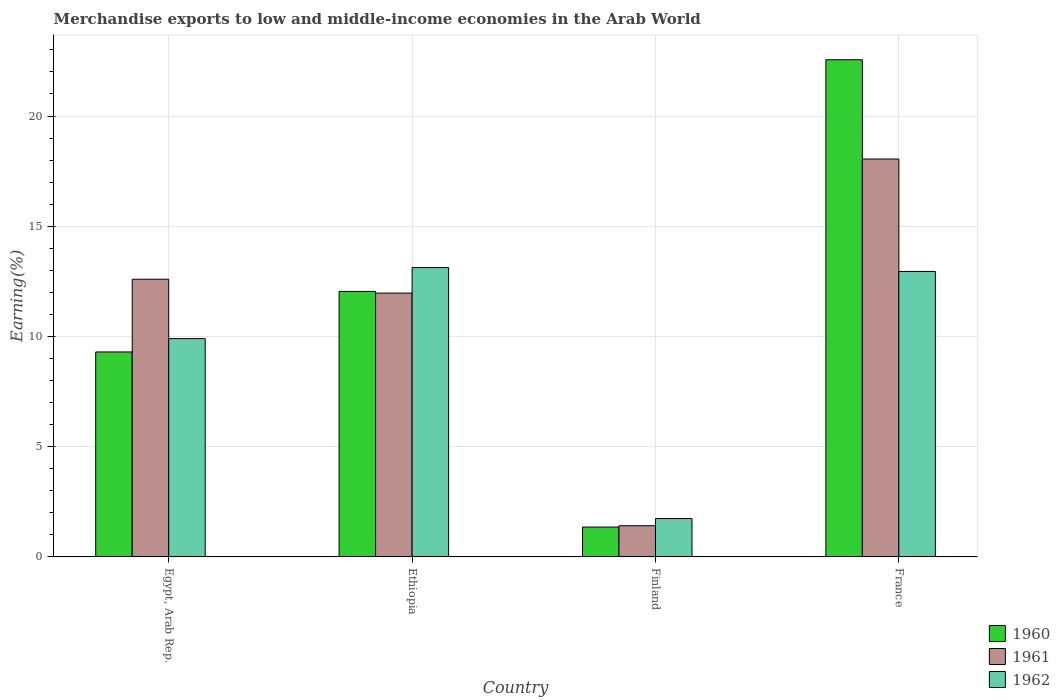How many groups of bars are there?
Provide a short and direct response. 4. Are the number of bars per tick equal to the number of legend labels?
Offer a very short reply. Yes. How many bars are there on the 3rd tick from the right?
Provide a short and direct response. 3. What is the label of the 2nd group of bars from the left?
Your response must be concise. Ethiopia. What is the percentage of amount earned from merchandise exports in 1961 in Egypt, Arab Rep.?
Your answer should be compact. 12.6. Across all countries, what is the maximum percentage of amount earned from merchandise exports in 1961?
Your answer should be very brief. 18.05. Across all countries, what is the minimum percentage of amount earned from merchandise exports in 1960?
Make the answer very short. 1.36. In which country was the percentage of amount earned from merchandise exports in 1961 maximum?
Provide a short and direct response. France. What is the total percentage of amount earned from merchandise exports in 1962 in the graph?
Your answer should be compact. 37.72. What is the difference between the percentage of amount earned from merchandise exports in 1960 in Egypt, Arab Rep. and that in Ethiopia?
Offer a terse response. -2.75. What is the difference between the percentage of amount earned from merchandise exports in 1960 in France and the percentage of amount earned from merchandise exports in 1961 in Ethiopia?
Offer a terse response. 10.58. What is the average percentage of amount earned from merchandise exports in 1961 per country?
Your response must be concise. 11.01. What is the difference between the percentage of amount earned from merchandise exports of/in 1962 and percentage of amount earned from merchandise exports of/in 1960 in Ethiopia?
Your answer should be very brief. 1.08. What is the ratio of the percentage of amount earned from merchandise exports in 1962 in Finland to that in France?
Make the answer very short. 0.13. Is the difference between the percentage of amount earned from merchandise exports in 1962 in Ethiopia and France greater than the difference between the percentage of amount earned from merchandise exports in 1960 in Ethiopia and France?
Provide a short and direct response. Yes. What is the difference between the highest and the second highest percentage of amount earned from merchandise exports in 1961?
Your response must be concise. 6.08. What is the difference between the highest and the lowest percentage of amount earned from merchandise exports in 1960?
Keep it short and to the point. 21.2. How many bars are there?
Give a very brief answer. 12. Are all the bars in the graph horizontal?
Provide a succinct answer. No. What is the difference between two consecutive major ticks on the Y-axis?
Your answer should be very brief. 5. Are the values on the major ticks of Y-axis written in scientific E-notation?
Give a very brief answer. No. Does the graph contain any zero values?
Your answer should be very brief. No. What is the title of the graph?
Ensure brevity in your answer.  Merchandise exports to low and middle-income economies in the Arab World. Does "1966" appear as one of the legend labels in the graph?
Provide a succinct answer. No. What is the label or title of the Y-axis?
Your answer should be very brief. Earning(%). What is the Earning(%) in 1960 in Egypt, Arab Rep.?
Give a very brief answer. 9.3. What is the Earning(%) of 1961 in Egypt, Arab Rep.?
Your answer should be compact. 12.6. What is the Earning(%) of 1962 in Egypt, Arab Rep.?
Your response must be concise. 9.9. What is the Earning(%) of 1960 in Ethiopia?
Provide a short and direct response. 12.04. What is the Earning(%) in 1961 in Ethiopia?
Provide a short and direct response. 11.97. What is the Earning(%) in 1962 in Ethiopia?
Provide a succinct answer. 13.12. What is the Earning(%) in 1960 in Finland?
Give a very brief answer. 1.36. What is the Earning(%) of 1961 in Finland?
Offer a terse response. 1.42. What is the Earning(%) of 1962 in Finland?
Provide a succinct answer. 1.74. What is the Earning(%) of 1960 in France?
Your response must be concise. 22.55. What is the Earning(%) of 1961 in France?
Give a very brief answer. 18.05. What is the Earning(%) in 1962 in France?
Give a very brief answer. 12.95. Across all countries, what is the maximum Earning(%) in 1960?
Your answer should be very brief. 22.55. Across all countries, what is the maximum Earning(%) of 1961?
Provide a succinct answer. 18.05. Across all countries, what is the maximum Earning(%) of 1962?
Ensure brevity in your answer.  13.12. Across all countries, what is the minimum Earning(%) of 1960?
Your answer should be compact. 1.36. Across all countries, what is the minimum Earning(%) in 1961?
Your answer should be very brief. 1.42. Across all countries, what is the minimum Earning(%) of 1962?
Offer a terse response. 1.74. What is the total Earning(%) of 1960 in the graph?
Keep it short and to the point. 45.25. What is the total Earning(%) of 1961 in the graph?
Your answer should be compact. 44.03. What is the total Earning(%) in 1962 in the graph?
Your answer should be very brief. 37.72. What is the difference between the Earning(%) in 1960 in Egypt, Arab Rep. and that in Ethiopia?
Give a very brief answer. -2.75. What is the difference between the Earning(%) of 1961 in Egypt, Arab Rep. and that in Ethiopia?
Offer a very short reply. 0.63. What is the difference between the Earning(%) of 1962 in Egypt, Arab Rep. and that in Ethiopia?
Your response must be concise. -3.22. What is the difference between the Earning(%) of 1960 in Egypt, Arab Rep. and that in Finland?
Provide a short and direct response. 7.94. What is the difference between the Earning(%) in 1961 in Egypt, Arab Rep. and that in Finland?
Keep it short and to the point. 11.18. What is the difference between the Earning(%) of 1962 in Egypt, Arab Rep. and that in Finland?
Offer a terse response. 8.16. What is the difference between the Earning(%) of 1960 in Egypt, Arab Rep. and that in France?
Ensure brevity in your answer.  -13.25. What is the difference between the Earning(%) of 1961 in Egypt, Arab Rep. and that in France?
Provide a succinct answer. -5.45. What is the difference between the Earning(%) in 1962 in Egypt, Arab Rep. and that in France?
Offer a very short reply. -3.05. What is the difference between the Earning(%) in 1960 in Ethiopia and that in Finland?
Your answer should be very brief. 10.69. What is the difference between the Earning(%) of 1961 in Ethiopia and that in Finland?
Provide a short and direct response. 10.55. What is the difference between the Earning(%) of 1962 in Ethiopia and that in Finland?
Provide a short and direct response. 11.38. What is the difference between the Earning(%) of 1960 in Ethiopia and that in France?
Provide a succinct answer. -10.51. What is the difference between the Earning(%) of 1961 in Ethiopia and that in France?
Your response must be concise. -6.08. What is the difference between the Earning(%) in 1962 in Ethiopia and that in France?
Make the answer very short. 0.18. What is the difference between the Earning(%) of 1960 in Finland and that in France?
Make the answer very short. -21.2. What is the difference between the Earning(%) in 1961 in Finland and that in France?
Your response must be concise. -16.63. What is the difference between the Earning(%) of 1962 in Finland and that in France?
Ensure brevity in your answer.  -11.21. What is the difference between the Earning(%) in 1960 in Egypt, Arab Rep. and the Earning(%) in 1961 in Ethiopia?
Offer a very short reply. -2.67. What is the difference between the Earning(%) in 1960 in Egypt, Arab Rep. and the Earning(%) in 1962 in Ethiopia?
Your answer should be very brief. -3.83. What is the difference between the Earning(%) of 1961 in Egypt, Arab Rep. and the Earning(%) of 1962 in Ethiopia?
Offer a very short reply. -0.53. What is the difference between the Earning(%) in 1960 in Egypt, Arab Rep. and the Earning(%) in 1961 in Finland?
Offer a very short reply. 7.88. What is the difference between the Earning(%) in 1960 in Egypt, Arab Rep. and the Earning(%) in 1962 in Finland?
Keep it short and to the point. 7.56. What is the difference between the Earning(%) in 1961 in Egypt, Arab Rep. and the Earning(%) in 1962 in Finland?
Keep it short and to the point. 10.85. What is the difference between the Earning(%) in 1960 in Egypt, Arab Rep. and the Earning(%) in 1961 in France?
Make the answer very short. -8.75. What is the difference between the Earning(%) in 1960 in Egypt, Arab Rep. and the Earning(%) in 1962 in France?
Offer a very short reply. -3.65. What is the difference between the Earning(%) of 1961 in Egypt, Arab Rep. and the Earning(%) of 1962 in France?
Offer a very short reply. -0.35. What is the difference between the Earning(%) of 1960 in Ethiopia and the Earning(%) of 1961 in Finland?
Your answer should be very brief. 10.63. What is the difference between the Earning(%) in 1960 in Ethiopia and the Earning(%) in 1962 in Finland?
Offer a terse response. 10.3. What is the difference between the Earning(%) in 1961 in Ethiopia and the Earning(%) in 1962 in Finland?
Ensure brevity in your answer.  10.23. What is the difference between the Earning(%) in 1960 in Ethiopia and the Earning(%) in 1961 in France?
Provide a succinct answer. -6.01. What is the difference between the Earning(%) of 1960 in Ethiopia and the Earning(%) of 1962 in France?
Keep it short and to the point. -0.91. What is the difference between the Earning(%) in 1961 in Ethiopia and the Earning(%) in 1962 in France?
Your answer should be very brief. -0.98. What is the difference between the Earning(%) in 1960 in Finland and the Earning(%) in 1961 in France?
Your answer should be very brief. -16.69. What is the difference between the Earning(%) in 1960 in Finland and the Earning(%) in 1962 in France?
Offer a very short reply. -11.59. What is the difference between the Earning(%) of 1961 in Finland and the Earning(%) of 1962 in France?
Give a very brief answer. -11.53. What is the average Earning(%) in 1960 per country?
Keep it short and to the point. 11.31. What is the average Earning(%) of 1961 per country?
Make the answer very short. 11.01. What is the average Earning(%) of 1962 per country?
Your answer should be compact. 9.43. What is the difference between the Earning(%) in 1960 and Earning(%) in 1961 in Egypt, Arab Rep.?
Your response must be concise. -3.3. What is the difference between the Earning(%) of 1960 and Earning(%) of 1962 in Egypt, Arab Rep.?
Provide a succinct answer. -0.61. What is the difference between the Earning(%) in 1961 and Earning(%) in 1962 in Egypt, Arab Rep.?
Provide a short and direct response. 2.69. What is the difference between the Earning(%) in 1960 and Earning(%) in 1961 in Ethiopia?
Ensure brevity in your answer.  0.08. What is the difference between the Earning(%) of 1960 and Earning(%) of 1962 in Ethiopia?
Keep it short and to the point. -1.08. What is the difference between the Earning(%) of 1961 and Earning(%) of 1962 in Ethiopia?
Provide a short and direct response. -1.16. What is the difference between the Earning(%) in 1960 and Earning(%) in 1961 in Finland?
Make the answer very short. -0.06. What is the difference between the Earning(%) of 1960 and Earning(%) of 1962 in Finland?
Provide a short and direct response. -0.38. What is the difference between the Earning(%) in 1961 and Earning(%) in 1962 in Finland?
Your answer should be compact. -0.33. What is the difference between the Earning(%) of 1960 and Earning(%) of 1961 in France?
Provide a short and direct response. 4.5. What is the difference between the Earning(%) in 1960 and Earning(%) in 1962 in France?
Provide a short and direct response. 9.6. What is the difference between the Earning(%) of 1961 and Earning(%) of 1962 in France?
Keep it short and to the point. 5.1. What is the ratio of the Earning(%) in 1960 in Egypt, Arab Rep. to that in Ethiopia?
Make the answer very short. 0.77. What is the ratio of the Earning(%) in 1961 in Egypt, Arab Rep. to that in Ethiopia?
Ensure brevity in your answer.  1.05. What is the ratio of the Earning(%) of 1962 in Egypt, Arab Rep. to that in Ethiopia?
Your answer should be very brief. 0.75. What is the ratio of the Earning(%) of 1960 in Egypt, Arab Rep. to that in Finland?
Provide a succinct answer. 6.86. What is the ratio of the Earning(%) in 1961 in Egypt, Arab Rep. to that in Finland?
Ensure brevity in your answer.  8.9. What is the ratio of the Earning(%) in 1962 in Egypt, Arab Rep. to that in Finland?
Offer a very short reply. 5.69. What is the ratio of the Earning(%) of 1960 in Egypt, Arab Rep. to that in France?
Keep it short and to the point. 0.41. What is the ratio of the Earning(%) of 1961 in Egypt, Arab Rep. to that in France?
Keep it short and to the point. 0.7. What is the ratio of the Earning(%) in 1962 in Egypt, Arab Rep. to that in France?
Your answer should be very brief. 0.76. What is the ratio of the Earning(%) of 1960 in Ethiopia to that in Finland?
Offer a very short reply. 8.88. What is the ratio of the Earning(%) in 1961 in Ethiopia to that in Finland?
Offer a terse response. 8.46. What is the ratio of the Earning(%) in 1962 in Ethiopia to that in Finland?
Your response must be concise. 7.54. What is the ratio of the Earning(%) in 1960 in Ethiopia to that in France?
Give a very brief answer. 0.53. What is the ratio of the Earning(%) in 1961 in Ethiopia to that in France?
Your response must be concise. 0.66. What is the ratio of the Earning(%) in 1962 in Ethiopia to that in France?
Your answer should be very brief. 1.01. What is the ratio of the Earning(%) of 1960 in Finland to that in France?
Your answer should be very brief. 0.06. What is the ratio of the Earning(%) of 1961 in Finland to that in France?
Your answer should be very brief. 0.08. What is the ratio of the Earning(%) of 1962 in Finland to that in France?
Provide a succinct answer. 0.13. What is the difference between the highest and the second highest Earning(%) of 1960?
Offer a terse response. 10.51. What is the difference between the highest and the second highest Earning(%) of 1961?
Ensure brevity in your answer.  5.45. What is the difference between the highest and the second highest Earning(%) of 1962?
Offer a very short reply. 0.18. What is the difference between the highest and the lowest Earning(%) in 1960?
Give a very brief answer. 21.2. What is the difference between the highest and the lowest Earning(%) of 1961?
Ensure brevity in your answer.  16.63. What is the difference between the highest and the lowest Earning(%) in 1962?
Offer a terse response. 11.38. 